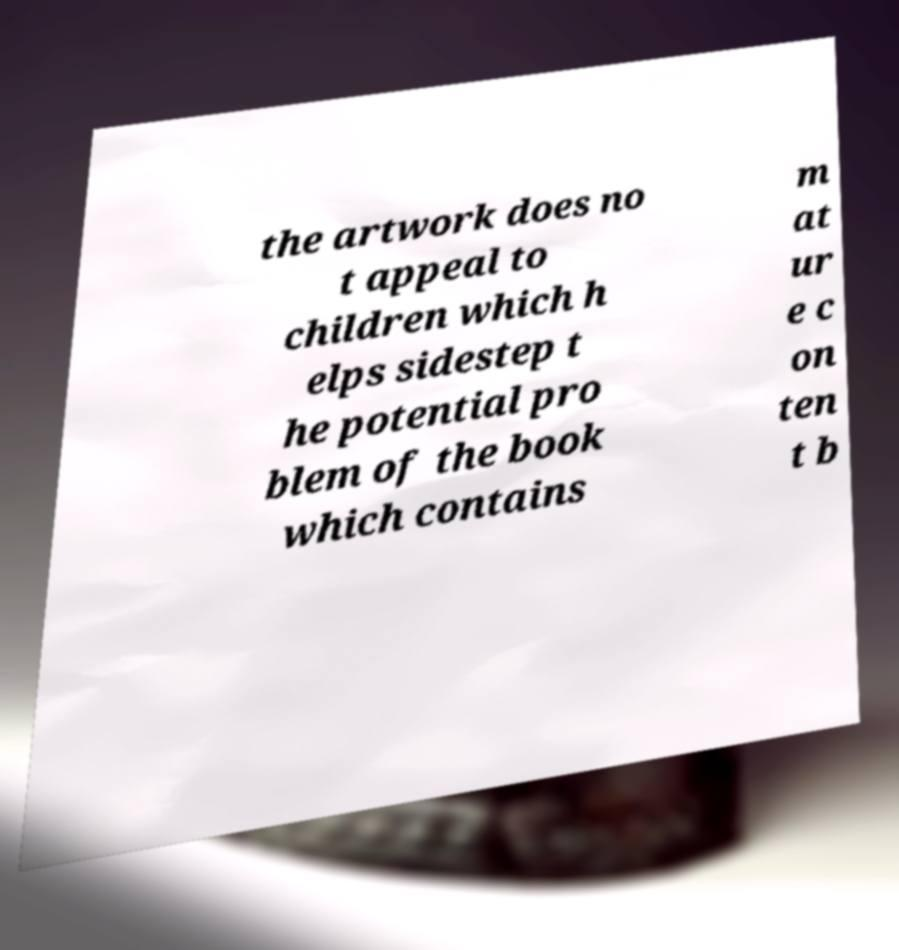I need the written content from this picture converted into text. Can you do that? the artwork does no t appeal to children which h elps sidestep t he potential pro blem of the book which contains m at ur e c on ten t b 